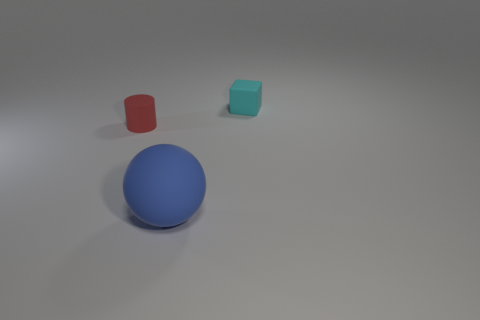Imagine if these objects were part of a game, what could be the rules? If these objects were part of a game, one might imagine a sorting challenge where the goal is to arrange the objects by color or size. Another possibility could be a balancing game, where the objective is to stack the objects without letting them fall over. 